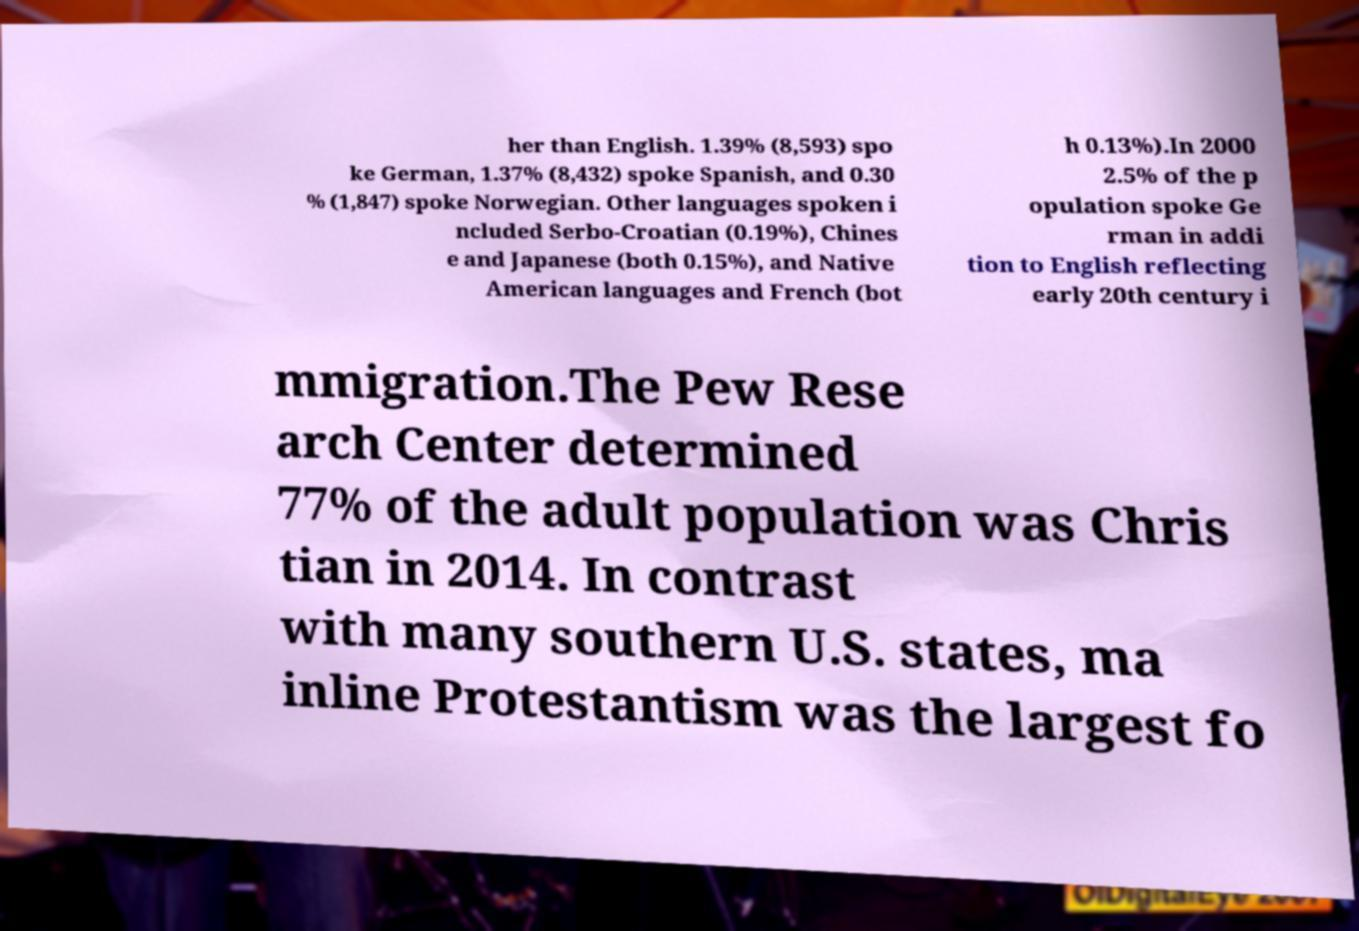Could you assist in decoding the text presented in this image and type it out clearly? her than English. 1.39% (8,593) spo ke German, 1.37% (8,432) spoke Spanish, and 0.30 % (1,847) spoke Norwegian. Other languages spoken i ncluded Serbo-Croatian (0.19%), Chines e and Japanese (both 0.15%), and Native American languages and French (bot h 0.13%).In 2000 2.5% of the p opulation spoke Ge rman in addi tion to English reflecting early 20th century i mmigration.The Pew Rese arch Center determined 77% of the adult population was Chris tian in 2014. In contrast with many southern U.S. states, ma inline Protestantism was the largest fo 